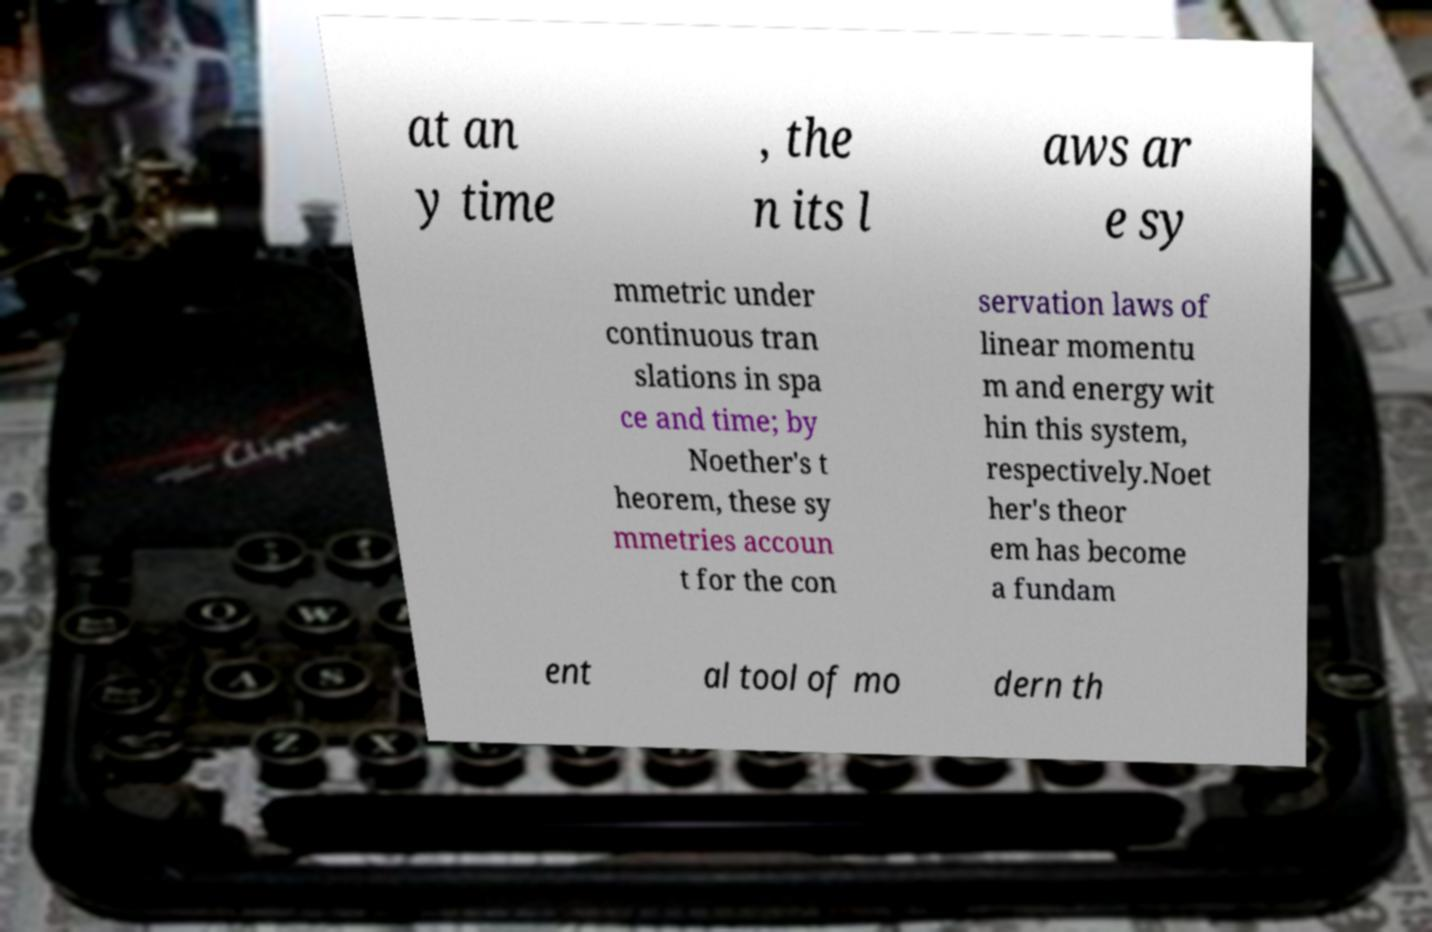What messages or text are displayed in this image? I need them in a readable, typed format. at an y time , the n its l aws ar e sy mmetric under continuous tran slations in spa ce and time; by Noether's t heorem, these sy mmetries accoun t for the con servation laws of linear momentu m and energy wit hin this system, respectively.Noet her's theor em has become a fundam ent al tool of mo dern th 